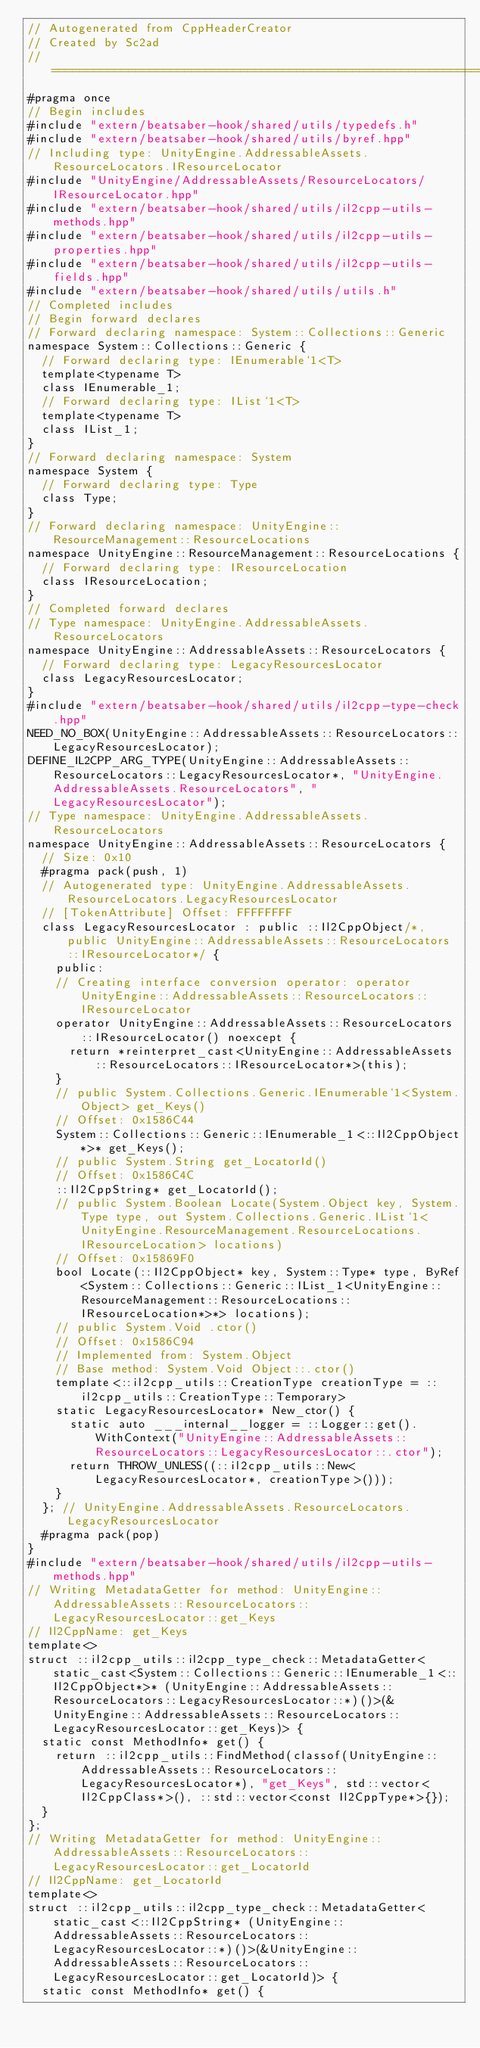<code> <loc_0><loc_0><loc_500><loc_500><_C++_>// Autogenerated from CppHeaderCreator
// Created by Sc2ad
// =========================================================================
#pragma once
// Begin includes
#include "extern/beatsaber-hook/shared/utils/typedefs.h"
#include "extern/beatsaber-hook/shared/utils/byref.hpp"
// Including type: UnityEngine.AddressableAssets.ResourceLocators.IResourceLocator
#include "UnityEngine/AddressableAssets/ResourceLocators/IResourceLocator.hpp"
#include "extern/beatsaber-hook/shared/utils/il2cpp-utils-methods.hpp"
#include "extern/beatsaber-hook/shared/utils/il2cpp-utils-properties.hpp"
#include "extern/beatsaber-hook/shared/utils/il2cpp-utils-fields.hpp"
#include "extern/beatsaber-hook/shared/utils/utils.h"
// Completed includes
// Begin forward declares
// Forward declaring namespace: System::Collections::Generic
namespace System::Collections::Generic {
  // Forward declaring type: IEnumerable`1<T>
  template<typename T>
  class IEnumerable_1;
  // Forward declaring type: IList`1<T>
  template<typename T>
  class IList_1;
}
// Forward declaring namespace: System
namespace System {
  // Forward declaring type: Type
  class Type;
}
// Forward declaring namespace: UnityEngine::ResourceManagement::ResourceLocations
namespace UnityEngine::ResourceManagement::ResourceLocations {
  // Forward declaring type: IResourceLocation
  class IResourceLocation;
}
// Completed forward declares
// Type namespace: UnityEngine.AddressableAssets.ResourceLocators
namespace UnityEngine::AddressableAssets::ResourceLocators {
  // Forward declaring type: LegacyResourcesLocator
  class LegacyResourcesLocator;
}
#include "extern/beatsaber-hook/shared/utils/il2cpp-type-check.hpp"
NEED_NO_BOX(UnityEngine::AddressableAssets::ResourceLocators::LegacyResourcesLocator);
DEFINE_IL2CPP_ARG_TYPE(UnityEngine::AddressableAssets::ResourceLocators::LegacyResourcesLocator*, "UnityEngine.AddressableAssets.ResourceLocators", "LegacyResourcesLocator");
// Type namespace: UnityEngine.AddressableAssets.ResourceLocators
namespace UnityEngine::AddressableAssets::ResourceLocators {
  // Size: 0x10
  #pragma pack(push, 1)
  // Autogenerated type: UnityEngine.AddressableAssets.ResourceLocators.LegacyResourcesLocator
  // [TokenAttribute] Offset: FFFFFFFF
  class LegacyResourcesLocator : public ::Il2CppObject/*, public UnityEngine::AddressableAssets::ResourceLocators::IResourceLocator*/ {
    public:
    // Creating interface conversion operator: operator UnityEngine::AddressableAssets::ResourceLocators::IResourceLocator
    operator UnityEngine::AddressableAssets::ResourceLocators::IResourceLocator() noexcept {
      return *reinterpret_cast<UnityEngine::AddressableAssets::ResourceLocators::IResourceLocator*>(this);
    }
    // public System.Collections.Generic.IEnumerable`1<System.Object> get_Keys()
    // Offset: 0x1586C44
    System::Collections::Generic::IEnumerable_1<::Il2CppObject*>* get_Keys();
    // public System.String get_LocatorId()
    // Offset: 0x1586C4C
    ::Il2CppString* get_LocatorId();
    // public System.Boolean Locate(System.Object key, System.Type type, out System.Collections.Generic.IList`1<UnityEngine.ResourceManagement.ResourceLocations.IResourceLocation> locations)
    // Offset: 0x15869F0
    bool Locate(::Il2CppObject* key, System::Type* type, ByRef<System::Collections::Generic::IList_1<UnityEngine::ResourceManagement::ResourceLocations::IResourceLocation*>*> locations);
    // public System.Void .ctor()
    // Offset: 0x1586C94
    // Implemented from: System.Object
    // Base method: System.Void Object::.ctor()
    template<::il2cpp_utils::CreationType creationType = ::il2cpp_utils::CreationType::Temporary>
    static LegacyResourcesLocator* New_ctor() {
      static auto ___internal__logger = ::Logger::get().WithContext("UnityEngine::AddressableAssets::ResourceLocators::LegacyResourcesLocator::.ctor");
      return THROW_UNLESS((::il2cpp_utils::New<LegacyResourcesLocator*, creationType>()));
    }
  }; // UnityEngine.AddressableAssets.ResourceLocators.LegacyResourcesLocator
  #pragma pack(pop)
}
#include "extern/beatsaber-hook/shared/utils/il2cpp-utils-methods.hpp"
// Writing MetadataGetter for method: UnityEngine::AddressableAssets::ResourceLocators::LegacyResourcesLocator::get_Keys
// Il2CppName: get_Keys
template<>
struct ::il2cpp_utils::il2cpp_type_check::MetadataGetter<static_cast<System::Collections::Generic::IEnumerable_1<::Il2CppObject*>* (UnityEngine::AddressableAssets::ResourceLocators::LegacyResourcesLocator::*)()>(&UnityEngine::AddressableAssets::ResourceLocators::LegacyResourcesLocator::get_Keys)> {
  static const MethodInfo* get() {
    return ::il2cpp_utils::FindMethod(classof(UnityEngine::AddressableAssets::ResourceLocators::LegacyResourcesLocator*), "get_Keys", std::vector<Il2CppClass*>(), ::std::vector<const Il2CppType*>{});
  }
};
// Writing MetadataGetter for method: UnityEngine::AddressableAssets::ResourceLocators::LegacyResourcesLocator::get_LocatorId
// Il2CppName: get_LocatorId
template<>
struct ::il2cpp_utils::il2cpp_type_check::MetadataGetter<static_cast<::Il2CppString* (UnityEngine::AddressableAssets::ResourceLocators::LegacyResourcesLocator::*)()>(&UnityEngine::AddressableAssets::ResourceLocators::LegacyResourcesLocator::get_LocatorId)> {
  static const MethodInfo* get() {</code> 